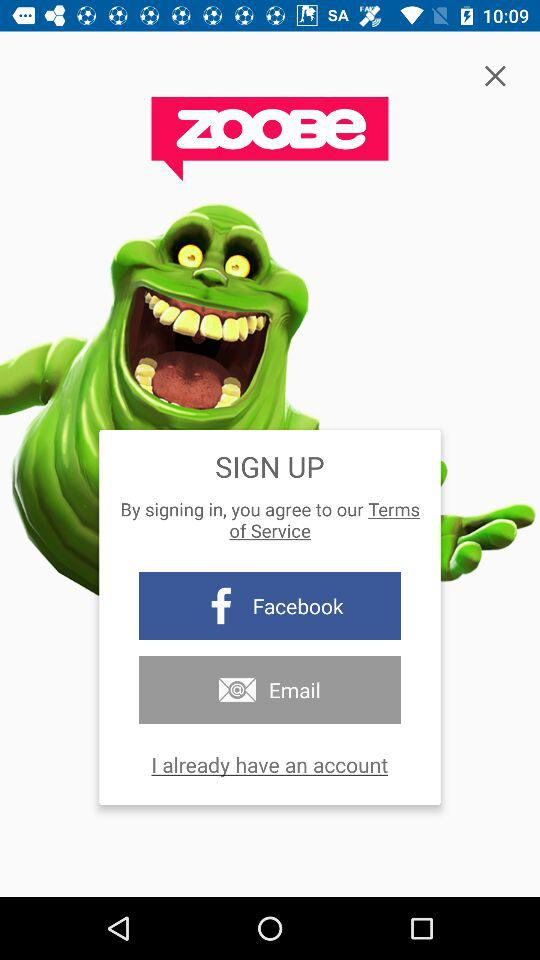Which are the different sign up options? The different sign up options are "Facebook" and "Email". 